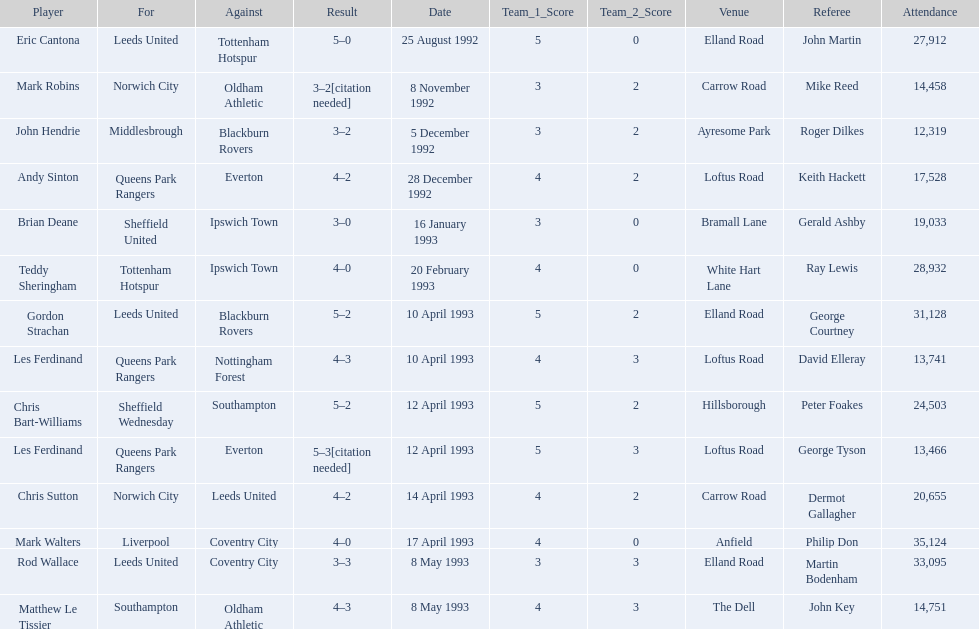What are the results? 5–0, 3–2[citation needed], 3–2, 4–2, 3–0, 4–0, 5–2, 4–3, 5–2, 5–3[citation needed], 4–2, 4–0, 3–3, 4–3. What result did mark robins have? 3–2[citation needed]. What other player had that result? John Hendrie. 